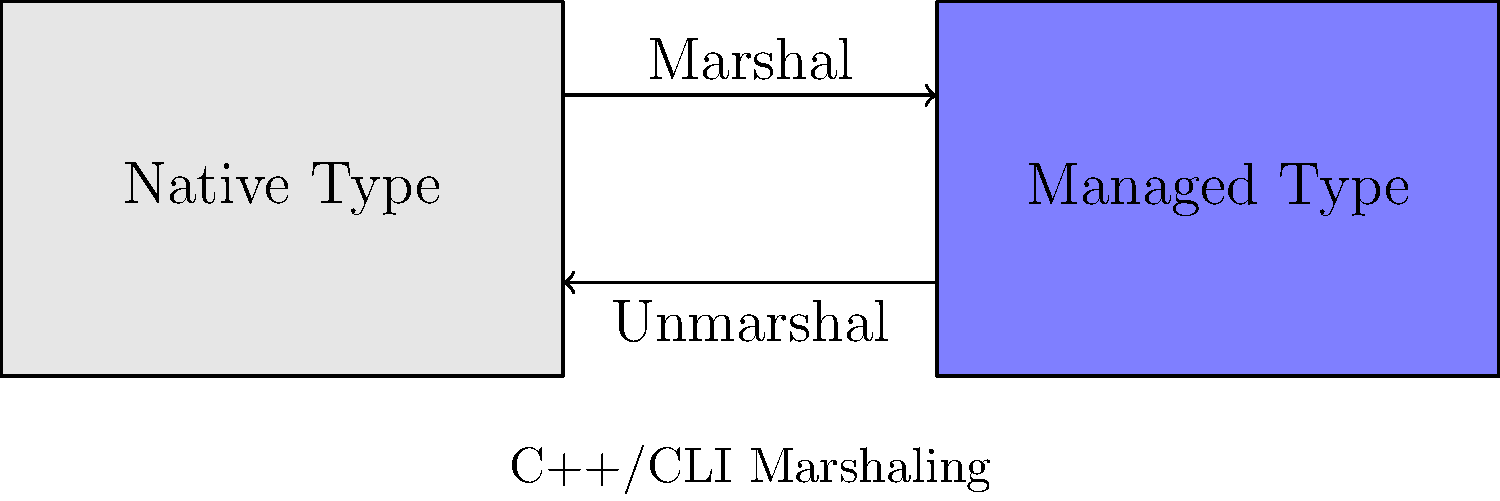Based on the block diagram, explain the process of marshaling between native and managed types in C++/CLI. What are the key components involved, and how does data flow between them? The marshaling process in C++/CLI involves converting data between native C++ types and managed .NET types. Here's a step-by-step explanation of the process:

1. Native Type: The left block represents native C++ types, which are unmanaged and exist in the traditional C++ memory model.

2. Managed Type: The right block represents managed .NET types, which are garbage-collected and exist in the Common Language Runtime (CLR) environment.

3. Marshal: The arrow pointing from native to managed represents the marshaling process. This involves:
   a. Converting native data structures to their managed equivalents
   b. Handling memory allocation for managed objects
   c. Ensuring type safety and compatibility

4. Unmarshal: The arrow pointing from managed to native represents the unmarshaling process. This involves:
   a. Converting managed data structures back to their native equivalents
   b. Properly releasing managed resources
   c. Ensuring data integrity during the conversion

5. C++/CLI Bridge: The entire diagram represents the C++/CLI environment, which serves as a bridge between native C++ code and the .NET framework.

The marshaling process is crucial for interoperability between native and managed code. It allows developers to leverage existing C++ libraries while taking advantage of .NET features. The C++/CLI compiler and runtime handle much of the marshaling automatically, but understanding this process is important for optimizing performance and avoiding potential issues like memory leaks or type mismatches.
Answer: Marshaling converts data between native C++ and managed .NET types, involving type conversion, memory management, and ensuring data integrity in both directions. 